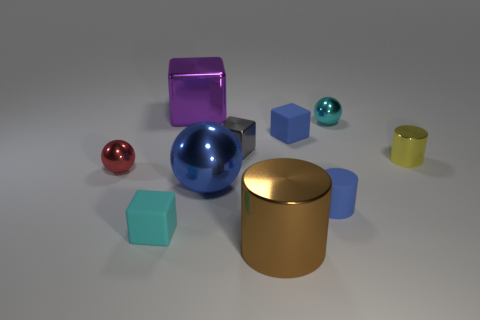Subtract all tiny metallic balls. How many balls are left? 1 Subtract all red spheres. How many spheres are left? 2 Subtract 1 cylinders. How many cylinders are left? 2 Add 1 red metallic things. How many red metallic things exist? 2 Subtract 1 red spheres. How many objects are left? 9 Subtract all blocks. How many objects are left? 6 Subtract all yellow cylinders. Subtract all brown cubes. How many cylinders are left? 2 Subtract all red cylinders. How many blue cubes are left? 1 Subtract all gray metal blocks. Subtract all tiny red objects. How many objects are left? 8 Add 9 large brown objects. How many large brown objects are left? 10 